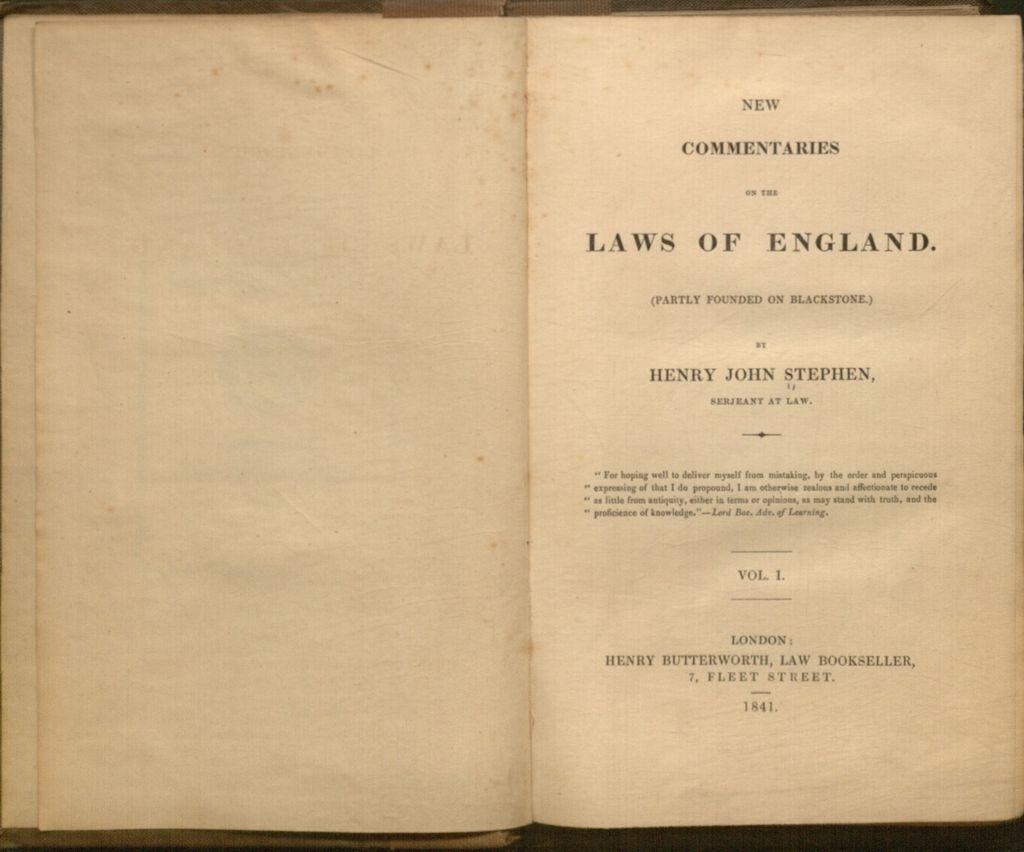When was this book first published?
Give a very brief answer. 1841. 